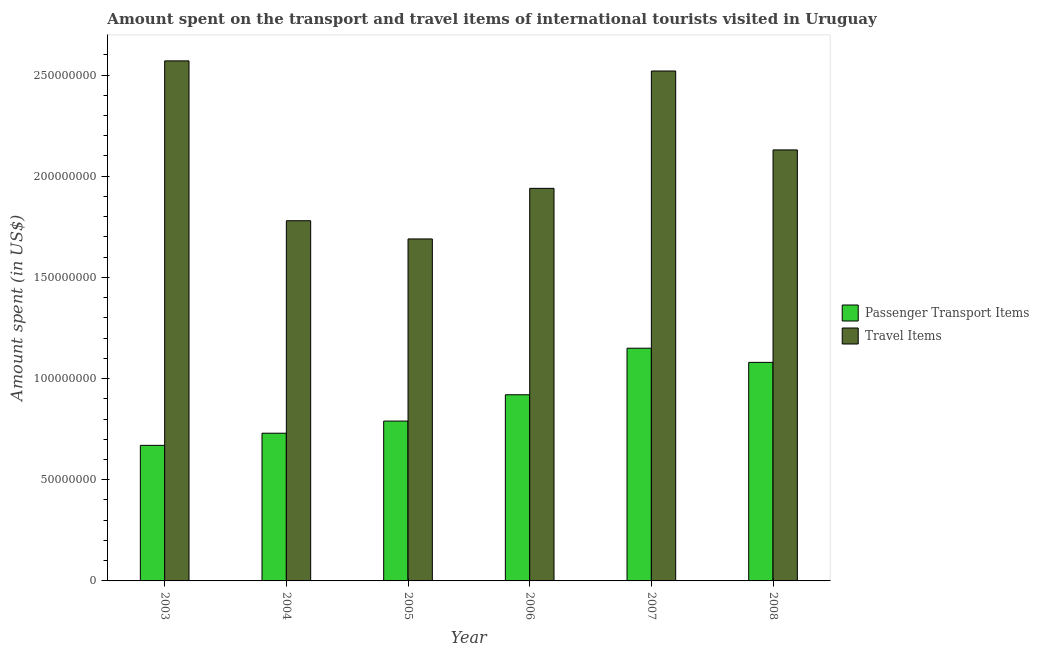How many different coloured bars are there?
Give a very brief answer. 2. How many groups of bars are there?
Provide a succinct answer. 6. Are the number of bars on each tick of the X-axis equal?
Your answer should be very brief. Yes. What is the label of the 5th group of bars from the left?
Your response must be concise. 2007. In how many cases, is the number of bars for a given year not equal to the number of legend labels?
Provide a short and direct response. 0. What is the amount spent in travel items in 2006?
Your response must be concise. 1.94e+08. Across all years, what is the maximum amount spent in travel items?
Keep it short and to the point. 2.57e+08. Across all years, what is the minimum amount spent in travel items?
Provide a succinct answer. 1.69e+08. In which year was the amount spent on passenger transport items minimum?
Offer a terse response. 2003. What is the total amount spent in travel items in the graph?
Provide a short and direct response. 1.26e+09. What is the difference between the amount spent in travel items in 2004 and that in 2008?
Your answer should be very brief. -3.50e+07. What is the difference between the amount spent on passenger transport items in 2004 and the amount spent in travel items in 2007?
Give a very brief answer. -4.20e+07. What is the average amount spent on passenger transport items per year?
Ensure brevity in your answer.  8.90e+07. In the year 2008, what is the difference between the amount spent in travel items and amount spent on passenger transport items?
Your response must be concise. 0. In how many years, is the amount spent in travel items greater than 80000000 US$?
Offer a terse response. 6. What is the ratio of the amount spent on passenger transport items in 2003 to that in 2008?
Your response must be concise. 0.62. What is the difference between the highest and the second highest amount spent in travel items?
Ensure brevity in your answer.  5.00e+06. What is the difference between the highest and the lowest amount spent in travel items?
Your response must be concise. 8.80e+07. Is the sum of the amount spent on passenger transport items in 2006 and 2007 greater than the maximum amount spent in travel items across all years?
Your answer should be very brief. Yes. What does the 1st bar from the left in 2003 represents?
Your answer should be very brief. Passenger Transport Items. What does the 2nd bar from the right in 2007 represents?
Make the answer very short. Passenger Transport Items. How many bars are there?
Offer a terse response. 12. How many years are there in the graph?
Keep it short and to the point. 6. Are the values on the major ticks of Y-axis written in scientific E-notation?
Provide a succinct answer. No. Does the graph contain any zero values?
Provide a succinct answer. No. How many legend labels are there?
Ensure brevity in your answer.  2. How are the legend labels stacked?
Your response must be concise. Vertical. What is the title of the graph?
Your answer should be very brief. Amount spent on the transport and travel items of international tourists visited in Uruguay. What is the label or title of the Y-axis?
Offer a terse response. Amount spent (in US$). What is the Amount spent (in US$) of Passenger Transport Items in 2003?
Make the answer very short. 6.70e+07. What is the Amount spent (in US$) of Travel Items in 2003?
Keep it short and to the point. 2.57e+08. What is the Amount spent (in US$) of Passenger Transport Items in 2004?
Offer a very short reply. 7.30e+07. What is the Amount spent (in US$) in Travel Items in 2004?
Keep it short and to the point. 1.78e+08. What is the Amount spent (in US$) in Passenger Transport Items in 2005?
Provide a succinct answer. 7.90e+07. What is the Amount spent (in US$) in Travel Items in 2005?
Offer a very short reply. 1.69e+08. What is the Amount spent (in US$) of Passenger Transport Items in 2006?
Your response must be concise. 9.20e+07. What is the Amount spent (in US$) of Travel Items in 2006?
Offer a terse response. 1.94e+08. What is the Amount spent (in US$) in Passenger Transport Items in 2007?
Offer a very short reply. 1.15e+08. What is the Amount spent (in US$) in Travel Items in 2007?
Your answer should be very brief. 2.52e+08. What is the Amount spent (in US$) in Passenger Transport Items in 2008?
Your answer should be very brief. 1.08e+08. What is the Amount spent (in US$) of Travel Items in 2008?
Provide a short and direct response. 2.13e+08. Across all years, what is the maximum Amount spent (in US$) of Passenger Transport Items?
Offer a very short reply. 1.15e+08. Across all years, what is the maximum Amount spent (in US$) of Travel Items?
Your answer should be very brief. 2.57e+08. Across all years, what is the minimum Amount spent (in US$) in Passenger Transport Items?
Your answer should be very brief. 6.70e+07. Across all years, what is the minimum Amount spent (in US$) of Travel Items?
Ensure brevity in your answer.  1.69e+08. What is the total Amount spent (in US$) in Passenger Transport Items in the graph?
Your response must be concise. 5.34e+08. What is the total Amount spent (in US$) in Travel Items in the graph?
Your answer should be very brief. 1.26e+09. What is the difference between the Amount spent (in US$) of Passenger Transport Items in 2003 and that in 2004?
Ensure brevity in your answer.  -6.00e+06. What is the difference between the Amount spent (in US$) in Travel Items in 2003 and that in 2004?
Provide a short and direct response. 7.90e+07. What is the difference between the Amount spent (in US$) in Passenger Transport Items in 2003 and that in 2005?
Your response must be concise. -1.20e+07. What is the difference between the Amount spent (in US$) of Travel Items in 2003 and that in 2005?
Give a very brief answer. 8.80e+07. What is the difference between the Amount spent (in US$) of Passenger Transport Items in 2003 and that in 2006?
Give a very brief answer. -2.50e+07. What is the difference between the Amount spent (in US$) in Travel Items in 2003 and that in 2006?
Make the answer very short. 6.30e+07. What is the difference between the Amount spent (in US$) of Passenger Transport Items in 2003 and that in 2007?
Your answer should be very brief. -4.80e+07. What is the difference between the Amount spent (in US$) in Passenger Transport Items in 2003 and that in 2008?
Your answer should be compact. -4.10e+07. What is the difference between the Amount spent (in US$) in Travel Items in 2003 and that in 2008?
Your answer should be very brief. 4.40e+07. What is the difference between the Amount spent (in US$) in Passenger Transport Items in 2004 and that in 2005?
Your answer should be compact. -6.00e+06. What is the difference between the Amount spent (in US$) of Travel Items in 2004 and that in 2005?
Keep it short and to the point. 9.00e+06. What is the difference between the Amount spent (in US$) in Passenger Transport Items in 2004 and that in 2006?
Give a very brief answer. -1.90e+07. What is the difference between the Amount spent (in US$) in Travel Items in 2004 and that in 2006?
Provide a succinct answer. -1.60e+07. What is the difference between the Amount spent (in US$) in Passenger Transport Items in 2004 and that in 2007?
Give a very brief answer. -4.20e+07. What is the difference between the Amount spent (in US$) in Travel Items in 2004 and that in 2007?
Provide a short and direct response. -7.40e+07. What is the difference between the Amount spent (in US$) of Passenger Transport Items in 2004 and that in 2008?
Keep it short and to the point. -3.50e+07. What is the difference between the Amount spent (in US$) of Travel Items in 2004 and that in 2008?
Provide a succinct answer. -3.50e+07. What is the difference between the Amount spent (in US$) of Passenger Transport Items in 2005 and that in 2006?
Provide a succinct answer. -1.30e+07. What is the difference between the Amount spent (in US$) in Travel Items in 2005 and that in 2006?
Give a very brief answer. -2.50e+07. What is the difference between the Amount spent (in US$) in Passenger Transport Items in 2005 and that in 2007?
Ensure brevity in your answer.  -3.60e+07. What is the difference between the Amount spent (in US$) of Travel Items in 2005 and that in 2007?
Your answer should be very brief. -8.30e+07. What is the difference between the Amount spent (in US$) of Passenger Transport Items in 2005 and that in 2008?
Provide a succinct answer. -2.90e+07. What is the difference between the Amount spent (in US$) of Travel Items in 2005 and that in 2008?
Provide a succinct answer. -4.40e+07. What is the difference between the Amount spent (in US$) in Passenger Transport Items in 2006 and that in 2007?
Make the answer very short. -2.30e+07. What is the difference between the Amount spent (in US$) in Travel Items in 2006 and that in 2007?
Your answer should be compact. -5.80e+07. What is the difference between the Amount spent (in US$) in Passenger Transport Items in 2006 and that in 2008?
Offer a very short reply. -1.60e+07. What is the difference between the Amount spent (in US$) of Travel Items in 2006 and that in 2008?
Give a very brief answer. -1.90e+07. What is the difference between the Amount spent (in US$) of Travel Items in 2007 and that in 2008?
Provide a succinct answer. 3.90e+07. What is the difference between the Amount spent (in US$) in Passenger Transport Items in 2003 and the Amount spent (in US$) in Travel Items in 2004?
Offer a terse response. -1.11e+08. What is the difference between the Amount spent (in US$) in Passenger Transport Items in 2003 and the Amount spent (in US$) in Travel Items in 2005?
Offer a very short reply. -1.02e+08. What is the difference between the Amount spent (in US$) of Passenger Transport Items in 2003 and the Amount spent (in US$) of Travel Items in 2006?
Offer a terse response. -1.27e+08. What is the difference between the Amount spent (in US$) in Passenger Transport Items in 2003 and the Amount spent (in US$) in Travel Items in 2007?
Offer a terse response. -1.85e+08. What is the difference between the Amount spent (in US$) in Passenger Transport Items in 2003 and the Amount spent (in US$) in Travel Items in 2008?
Provide a succinct answer. -1.46e+08. What is the difference between the Amount spent (in US$) in Passenger Transport Items in 2004 and the Amount spent (in US$) in Travel Items in 2005?
Make the answer very short. -9.60e+07. What is the difference between the Amount spent (in US$) of Passenger Transport Items in 2004 and the Amount spent (in US$) of Travel Items in 2006?
Offer a terse response. -1.21e+08. What is the difference between the Amount spent (in US$) of Passenger Transport Items in 2004 and the Amount spent (in US$) of Travel Items in 2007?
Provide a succinct answer. -1.79e+08. What is the difference between the Amount spent (in US$) in Passenger Transport Items in 2004 and the Amount spent (in US$) in Travel Items in 2008?
Your answer should be very brief. -1.40e+08. What is the difference between the Amount spent (in US$) in Passenger Transport Items in 2005 and the Amount spent (in US$) in Travel Items in 2006?
Your response must be concise. -1.15e+08. What is the difference between the Amount spent (in US$) in Passenger Transport Items in 2005 and the Amount spent (in US$) in Travel Items in 2007?
Keep it short and to the point. -1.73e+08. What is the difference between the Amount spent (in US$) of Passenger Transport Items in 2005 and the Amount spent (in US$) of Travel Items in 2008?
Your answer should be very brief. -1.34e+08. What is the difference between the Amount spent (in US$) in Passenger Transport Items in 2006 and the Amount spent (in US$) in Travel Items in 2007?
Offer a very short reply. -1.60e+08. What is the difference between the Amount spent (in US$) in Passenger Transport Items in 2006 and the Amount spent (in US$) in Travel Items in 2008?
Offer a very short reply. -1.21e+08. What is the difference between the Amount spent (in US$) of Passenger Transport Items in 2007 and the Amount spent (in US$) of Travel Items in 2008?
Make the answer very short. -9.80e+07. What is the average Amount spent (in US$) in Passenger Transport Items per year?
Ensure brevity in your answer.  8.90e+07. What is the average Amount spent (in US$) of Travel Items per year?
Your answer should be very brief. 2.10e+08. In the year 2003, what is the difference between the Amount spent (in US$) of Passenger Transport Items and Amount spent (in US$) of Travel Items?
Provide a short and direct response. -1.90e+08. In the year 2004, what is the difference between the Amount spent (in US$) in Passenger Transport Items and Amount spent (in US$) in Travel Items?
Offer a very short reply. -1.05e+08. In the year 2005, what is the difference between the Amount spent (in US$) of Passenger Transport Items and Amount spent (in US$) of Travel Items?
Offer a terse response. -9.00e+07. In the year 2006, what is the difference between the Amount spent (in US$) of Passenger Transport Items and Amount spent (in US$) of Travel Items?
Offer a terse response. -1.02e+08. In the year 2007, what is the difference between the Amount spent (in US$) in Passenger Transport Items and Amount spent (in US$) in Travel Items?
Your answer should be very brief. -1.37e+08. In the year 2008, what is the difference between the Amount spent (in US$) of Passenger Transport Items and Amount spent (in US$) of Travel Items?
Offer a terse response. -1.05e+08. What is the ratio of the Amount spent (in US$) of Passenger Transport Items in 2003 to that in 2004?
Ensure brevity in your answer.  0.92. What is the ratio of the Amount spent (in US$) of Travel Items in 2003 to that in 2004?
Make the answer very short. 1.44. What is the ratio of the Amount spent (in US$) of Passenger Transport Items in 2003 to that in 2005?
Give a very brief answer. 0.85. What is the ratio of the Amount spent (in US$) of Travel Items in 2003 to that in 2005?
Make the answer very short. 1.52. What is the ratio of the Amount spent (in US$) in Passenger Transport Items in 2003 to that in 2006?
Your answer should be compact. 0.73. What is the ratio of the Amount spent (in US$) in Travel Items in 2003 to that in 2006?
Your response must be concise. 1.32. What is the ratio of the Amount spent (in US$) in Passenger Transport Items in 2003 to that in 2007?
Your response must be concise. 0.58. What is the ratio of the Amount spent (in US$) of Travel Items in 2003 to that in 2007?
Ensure brevity in your answer.  1.02. What is the ratio of the Amount spent (in US$) in Passenger Transport Items in 2003 to that in 2008?
Keep it short and to the point. 0.62. What is the ratio of the Amount spent (in US$) of Travel Items in 2003 to that in 2008?
Offer a very short reply. 1.21. What is the ratio of the Amount spent (in US$) of Passenger Transport Items in 2004 to that in 2005?
Your response must be concise. 0.92. What is the ratio of the Amount spent (in US$) of Travel Items in 2004 to that in 2005?
Keep it short and to the point. 1.05. What is the ratio of the Amount spent (in US$) of Passenger Transport Items in 2004 to that in 2006?
Give a very brief answer. 0.79. What is the ratio of the Amount spent (in US$) in Travel Items in 2004 to that in 2006?
Ensure brevity in your answer.  0.92. What is the ratio of the Amount spent (in US$) in Passenger Transport Items in 2004 to that in 2007?
Keep it short and to the point. 0.63. What is the ratio of the Amount spent (in US$) of Travel Items in 2004 to that in 2007?
Make the answer very short. 0.71. What is the ratio of the Amount spent (in US$) of Passenger Transport Items in 2004 to that in 2008?
Provide a short and direct response. 0.68. What is the ratio of the Amount spent (in US$) in Travel Items in 2004 to that in 2008?
Keep it short and to the point. 0.84. What is the ratio of the Amount spent (in US$) of Passenger Transport Items in 2005 to that in 2006?
Make the answer very short. 0.86. What is the ratio of the Amount spent (in US$) in Travel Items in 2005 to that in 2006?
Keep it short and to the point. 0.87. What is the ratio of the Amount spent (in US$) in Passenger Transport Items in 2005 to that in 2007?
Offer a terse response. 0.69. What is the ratio of the Amount spent (in US$) of Travel Items in 2005 to that in 2007?
Your answer should be very brief. 0.67. What is the ratio of the Amount spent (in US$) in Passenger Transport Items in 2005 to that in 2008?
Keep it short and to the point. 0.73. What is the ratio of the Amount spent (in US$) in Travel Items in 2005 to that in 2008?
Your response must be concise. 0.79. What is the ratio of the Amount spent (in US$) of Travel Items in 2006 to that in 2007?
Make the answer very short. 0.77. What is the ratio of the Amount spent (in US$) of Passenger Transport Items in 2006 to that in 2008?
Offer a very short reply. 0.85. What is the ratio of the Amount spent (in US$) in Travel Items in 2006 to that in 2008?
Provide a short and direct response. 0.91. What is the ratio of the Amount spent (in US$) in Passenger Transport Items in 2007 to that in 2008?
Provide a short and direct response. 1.06. What is the ratio of the Amount spent (in US$) in Travel Items in 2007 to that in 2008?
Your answer should be compact. 1.18. What is the difference between the highest and the second highest Amount spent (in US$) in Passenger Transport Items?
Keep it short and to the point. 7.00e+06. What is the difference between the highest and the lowest Amount spent (in US$) of Passenger Transport Items?
Your answer should be very brief. 4.80e+07. What is the difference between the highest and the lowest Amount spent (in US$) in Travel Items?
Offer a terse response. 8.80e+07. 